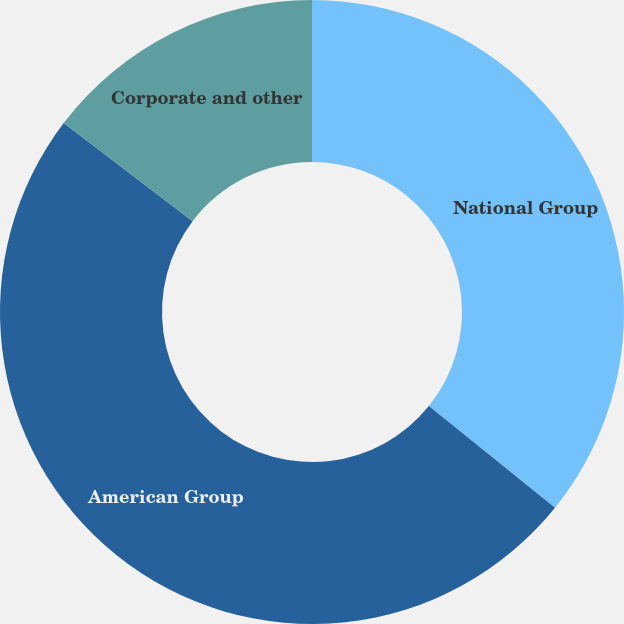<chart> <loc_0><loc_0><loc_500><loc_500><pie_chart><fcel>National Group<fcel>American Group<fcel>Corporate and other<nl><fcel>35.79%<fcel>49.56%<fcel>14.65%<nl></chart> 